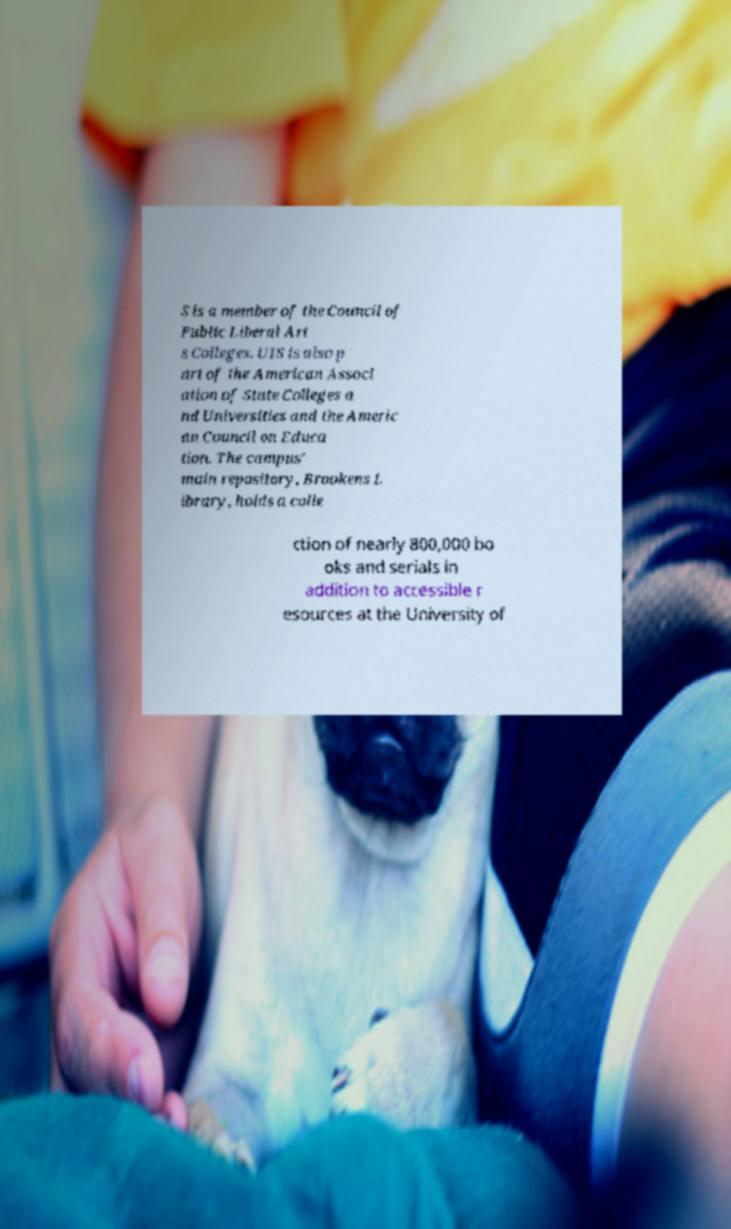I need the written content from this picture converted into text. Can you do that? S is a member of the Council of Public Liberal Art s Colleges. UIS is also p art of the American Associ ation of State Colleges a nd Universities and the Americ an Council on Educa tion. The campus' main repository, Brookens L ibrary, holds a colle ction of nearly 800,000 bo oks and serials in addition to accessible r esources at the University of 